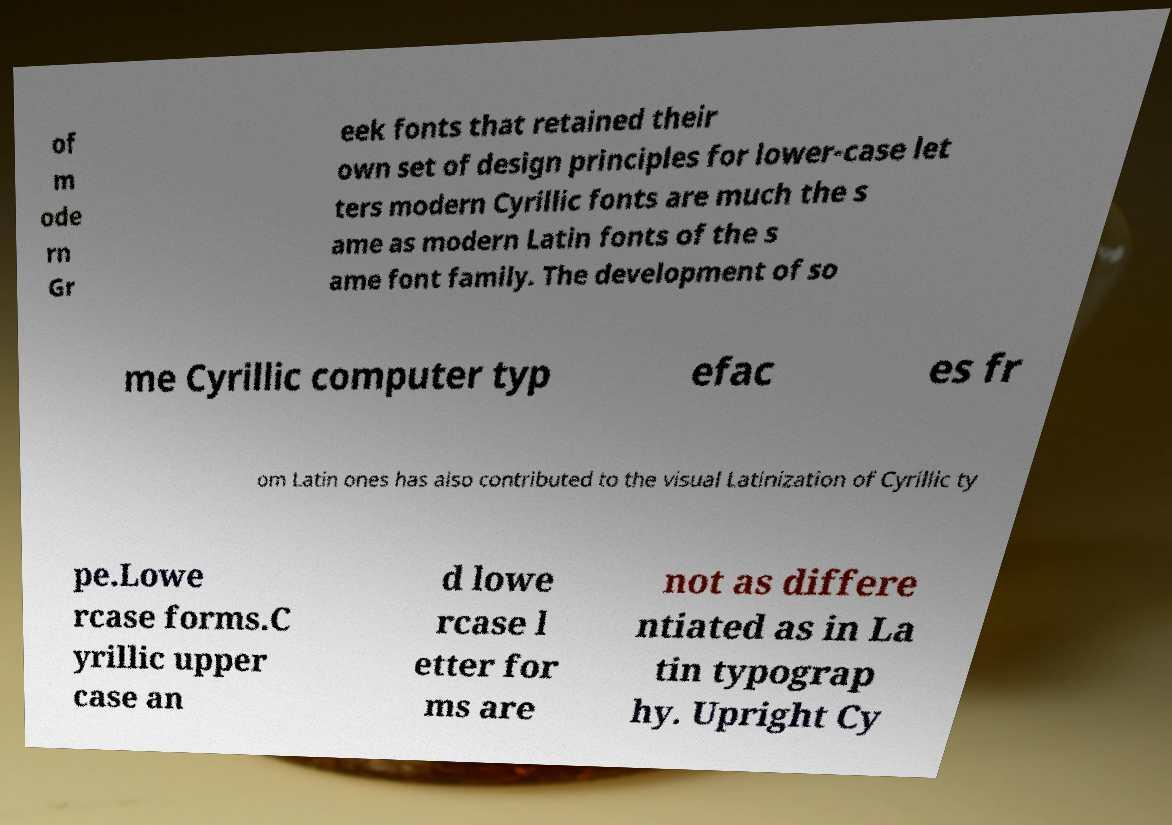What messages or text are displayed in this image? I need them in a readable, typed format. of m ode rn Gr eek fonts that retained their own set of design principles for lower-case let ters modern Cyrillic fonts are much the s ame as modern Latin fonts of the s ame font family. The development of so me Cyrillic computer typ efac es fr om Latin ones has also contributed to the visual Latinization of Cyrillic ty pe.Lowe rcase forms.C yrillic upper case an d lowe rcase l etter for ms are not as differe ntiated as in La tin typograp hy. Upright Cy 